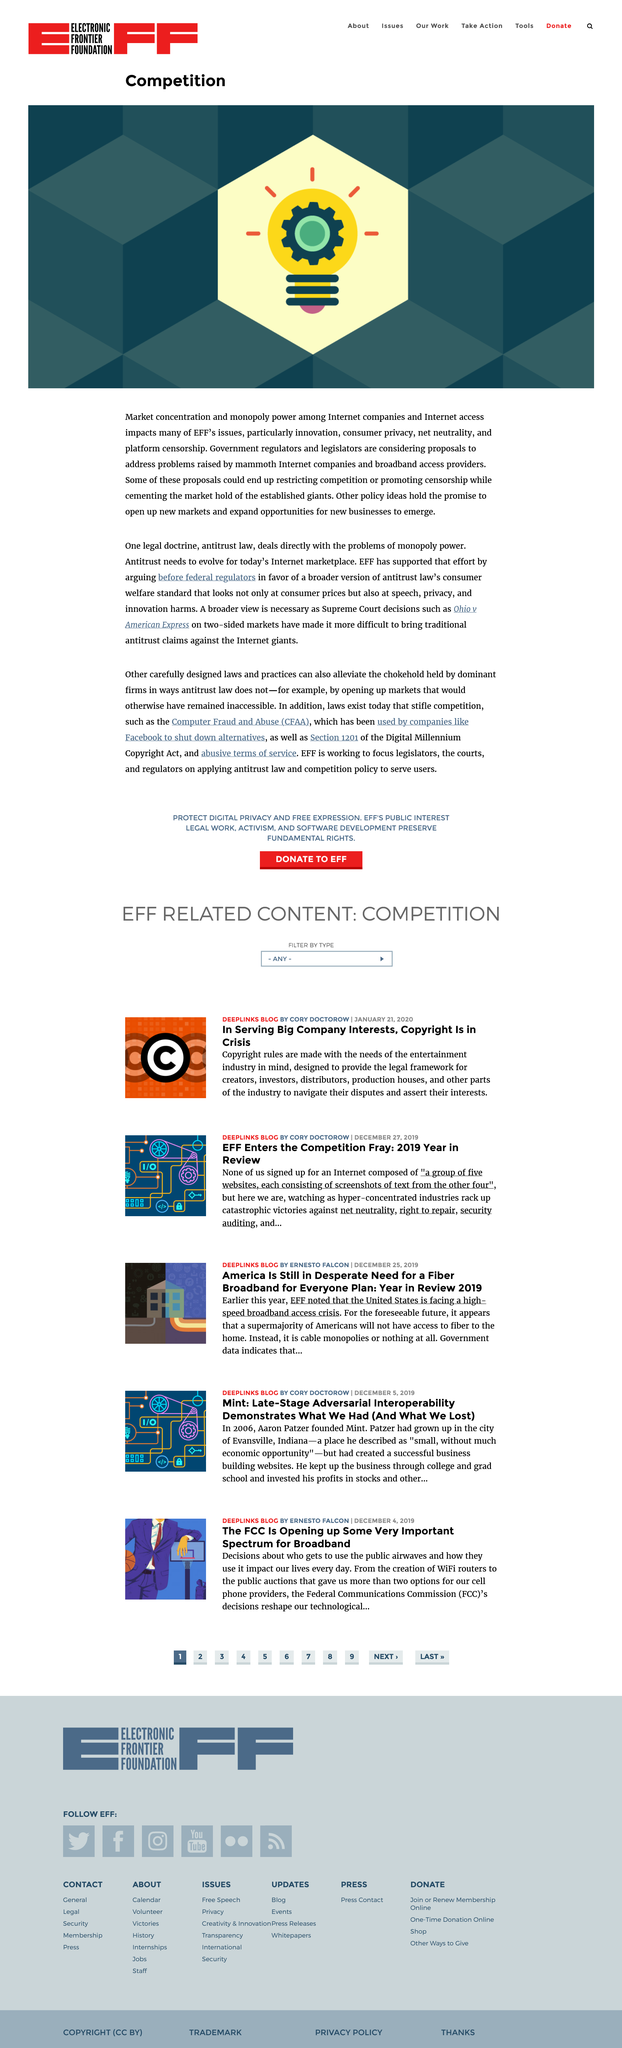Indicate a few pertinent items in this graphic. Government regulators and legislators are considering a proposal to address the problems caused by internet companies. Market concentration and monopoly power among Internet companies and Internet access providers have a significant impact on issues such as innovation, consumer privacy, net neutrality, and platform censorship, as highlighted by the Electronic Frontier Foundation (EFF). Some proposals to address problems raised by internet companies and broadband access providers may restrict competition, promote censorship, cement the market hold of the established giants, while others may open up new markets and allow new businesses to emerge. 